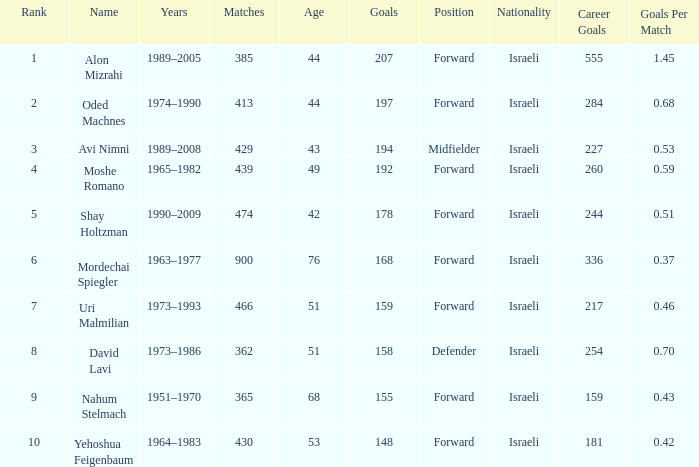What is the Rank of the player with 158 Goals in more than 362 Matches? 0.0. 